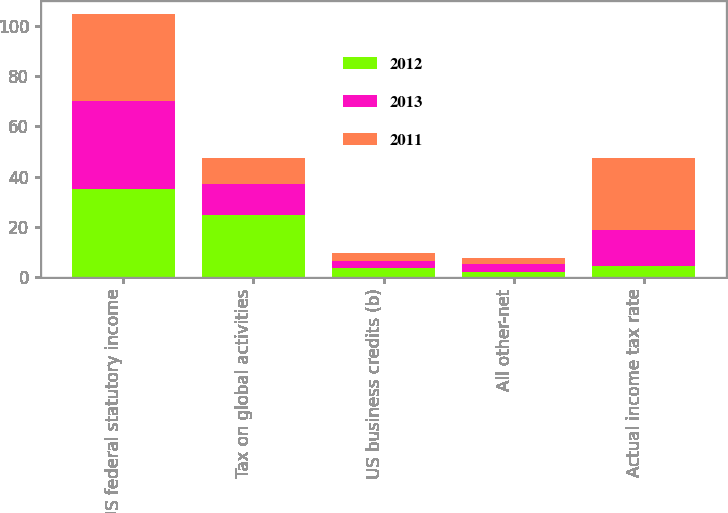Convert chart. <chart><loc_0><loc_0><loc_500><loc_500><stacked_bar_chart><ecel><fcel>US federal statutory income<fcel>Tax on global activities<fcel>US business credits (b)<fcel>All other-net<fcel>Actual income tax rate<nl><fcel>2012<fcel>35<fcel>24.7<fcel>3.6<fcel>1.8<fcel>4.2<nl><fcel>2013<fcel>35<fcel>12.5<fcel>2.6<fcel>3.4<fcel>14.6<nl><fcel>2011<fcel>35<fcel>10.4<fcel>3.2<fcel>2.2<fcel>28.5<nl></chart> 